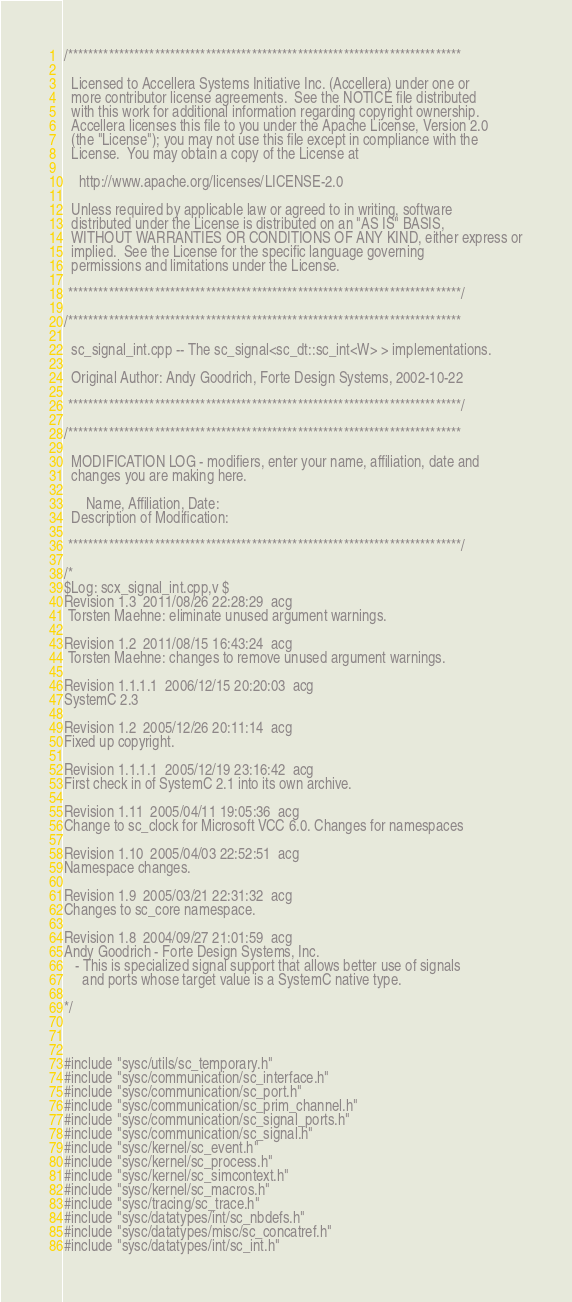Convert code to text. <code><loc_0><loc_0><loc_500><loc_500><_C++_>/*****************************************************************************

  Licensed to Accellera Systems Initiative Inc. (Accellera) under one or
  more contributor license agreements.  See the NOTICE file distributed
  with this work for additional information regarding copyright ownership.
  Accellera licenses this file to you under the Apache License, Version 2.0
  (the "License"); you may not use this file except in compliance with the
  License.  You may obtain a copy of the License at

    http://www.apache.org/licenses/LICENSE-2.0

  Unless required by applicable law or agreed to in writing, software
  distributed under the License is distributed on an "AS IS" BASIS,
  WITHOUT WARRANTIES OR CONDITIONS OF ANY KIND, either express or
  implied.  See the License for the specific language governing
  permissions and limitations under the License.

 *****************************************************************************/

/*****************************************************************************

  sc_signal_int.cpp -- The sc_signal<sc_dt::sc_int<W> > implementations.

  Original Author: Andy Goodrich, Forte Design Systems, 2002-10-22

 *****************************************************************************/

/*****************************************************************************

  MODIFICATION LOG - modifiers, enter your name, affiliation, date and
  changes you are making here.

      Name, Affiliation, Date:
  Description of Modification:

 *****************************************************************************/

/* 
$Log: scx_signal_int.cpp,v $
Revision 1.3  2011/08/26 22:28:29  acg
 Torsten Maehne: eliminate unused argument warnings.

Revision 1.2  2011/08/15 16:43:24  acg
 Torsten Maehne: changes to remove unused argument warnings.

Revision 1.1.1.1  2006/12/15 20:20:03  acg
SystemC 2.3

Revision 1.2  2005/12/26 20:11:14  acg
Fixed up copyright.

Revision 1.1.1.1  2005/12/19 23:16:42  acg
First check in of SystemC 2.1 into its own archive.

Revision 1.11  2005/04/11 19:05:36  acg
Change to sc_clock for Microsoft VCC 6.0. Changes for namespaces

Revision 1.10  2005/04/03 22:52:51  acg
Namespace changes.

Revision 1.9  2005/03/21 22:31:32  acg
Changes to sc_core namespace.

Revision 1.8  2004/09/27 21:01:59  acg
Andy Goodrich - Forte Design Systems, Inc.
   - This is specialized signal support that allows better use of signals
     and ports whose target value is a SystemC native type.

*/



#include "sysc/utils/sc_temporary.h"
#include "sysc/communication/sc_interface.h"
#include "sysc/communication/sc_port.h"
#include "sysc/communication/sc_prim_channel.h"
#include "sysc/communication/sc_signal_ports.h"
#include "sysc/communication/sc_signal.h"
#include "sysc/kernel/sc_event.h"
#include "sysc/kernel/sc_process.h"
#include "sysc/kernel/sc_simcontext.h"
#include "sysc/kernel/sc_macros.h"
#include "sysc/tracing/sc_trace.h"
#include "sysc/datatypes/int/sc_nbdefs.h"
#include "sysc/datatypes/misc/sc_concatref.h"
#include "sysc/datatypes/int/sc_int.h"</code> 